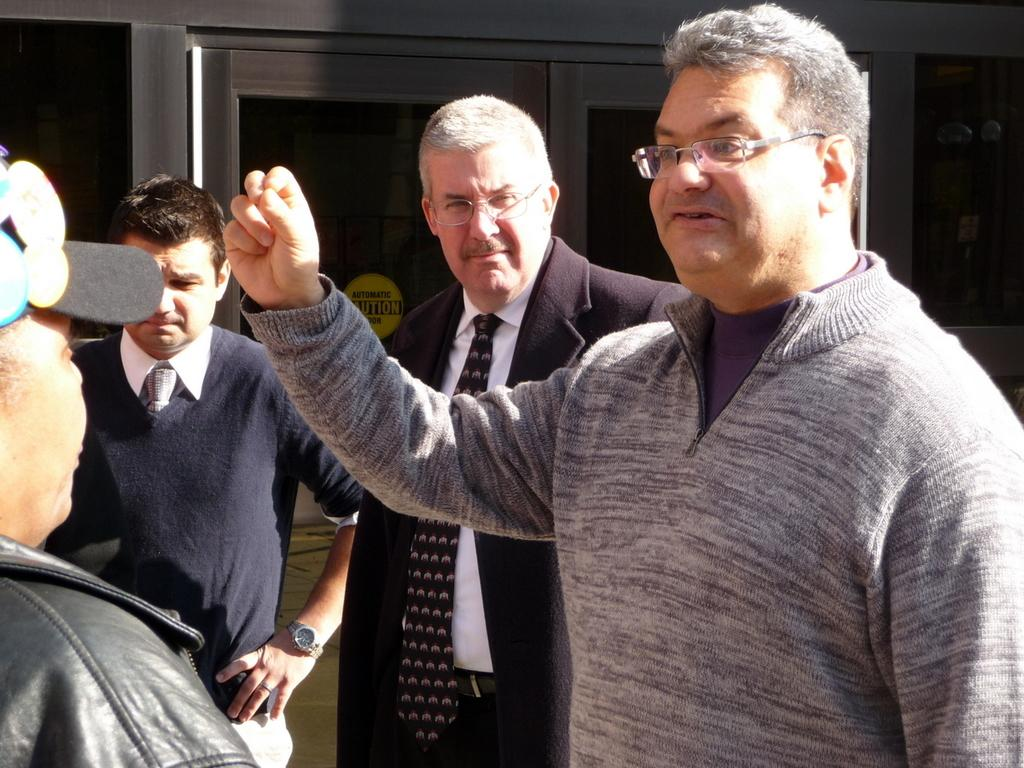How many people are in the image? There are four people in the image. What are the people doing in the image? The people are standing near a glass door. What is on the glass door? There is a yellow sticker with text on the glass door. What can be seen on the wall in the image? There is a black poster on the wall. What type of powder is being used by the people in the image? There is no powder visible or mentioned in the image. 